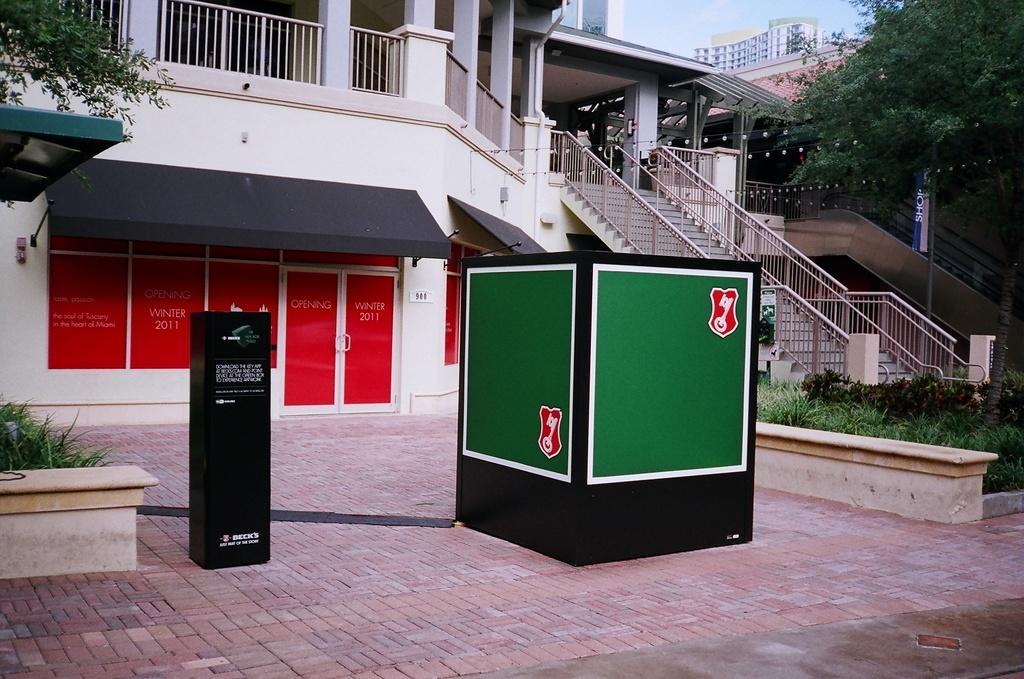Can you describe this image briefly? In this image I can see the ground, a black colored object on the ground and a huge box which is green and black in color on the ground. I can see some grass, few trees, few stairs, the railing and few buildings. In the background I can see the sky. 